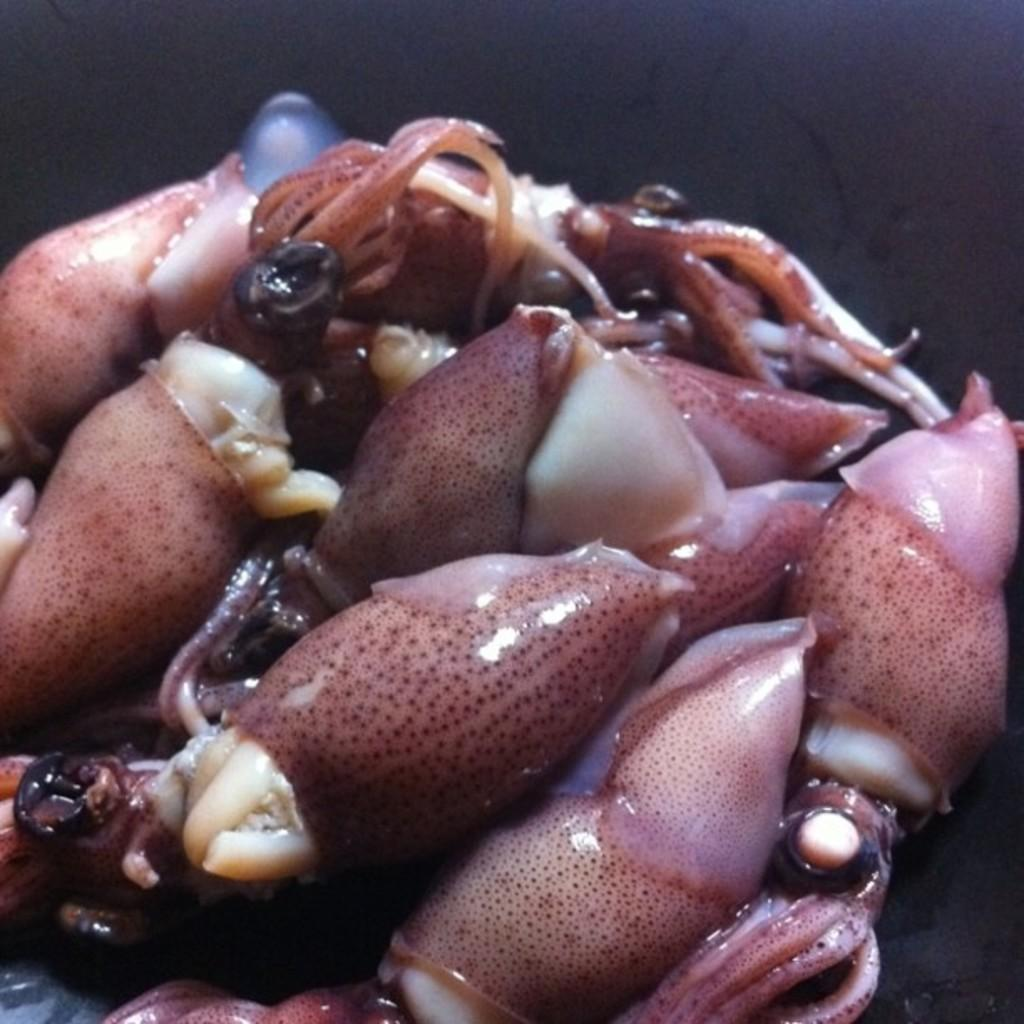What type of animals can be seen in the image? There are sea animals in the image. What color are the sea animals? The sea animals are pink in color. What distinguishing feature do the sea animals have? The sea animals have dots on them. How many weeks does it take for the sea animals to change their color? The image does not provide information about the sea animals changing color or the passage of time, so it is not possible to answer this question. 